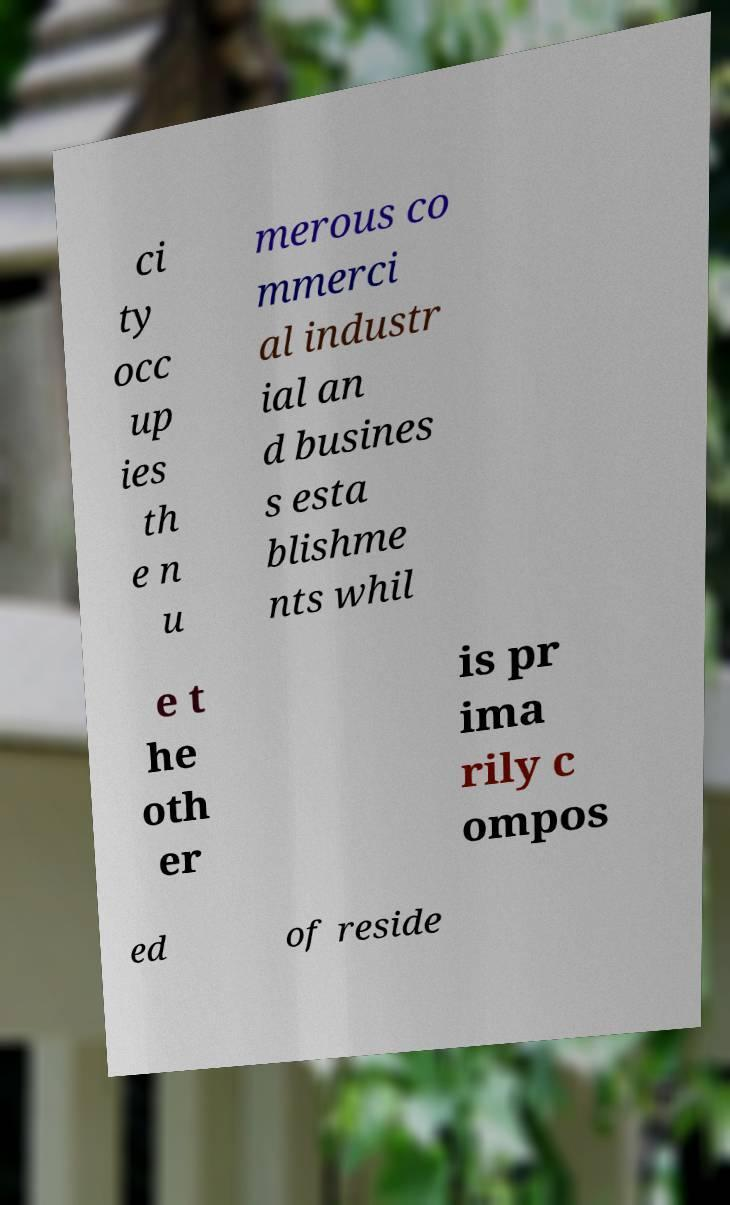Please read and relay the text visible in this image. What does it say? ci ty occ up ies th e n u merous co mmerci al industr ial an d busines s esta blishme nts whil e t he oth er is pr ima rily c ompos ed of reside 